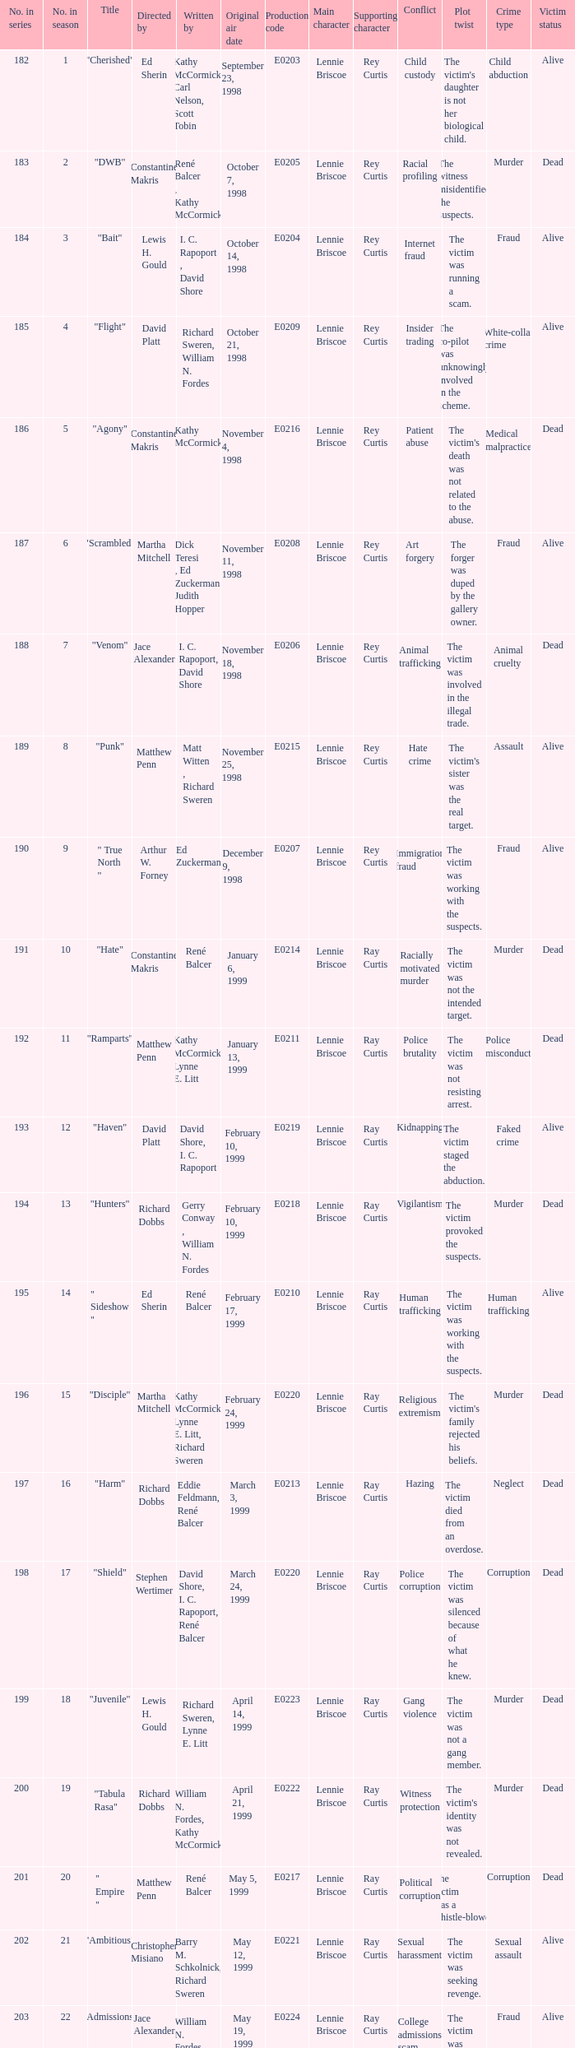The episode with the original air date January 6, 1999, has what production code? E0214. 